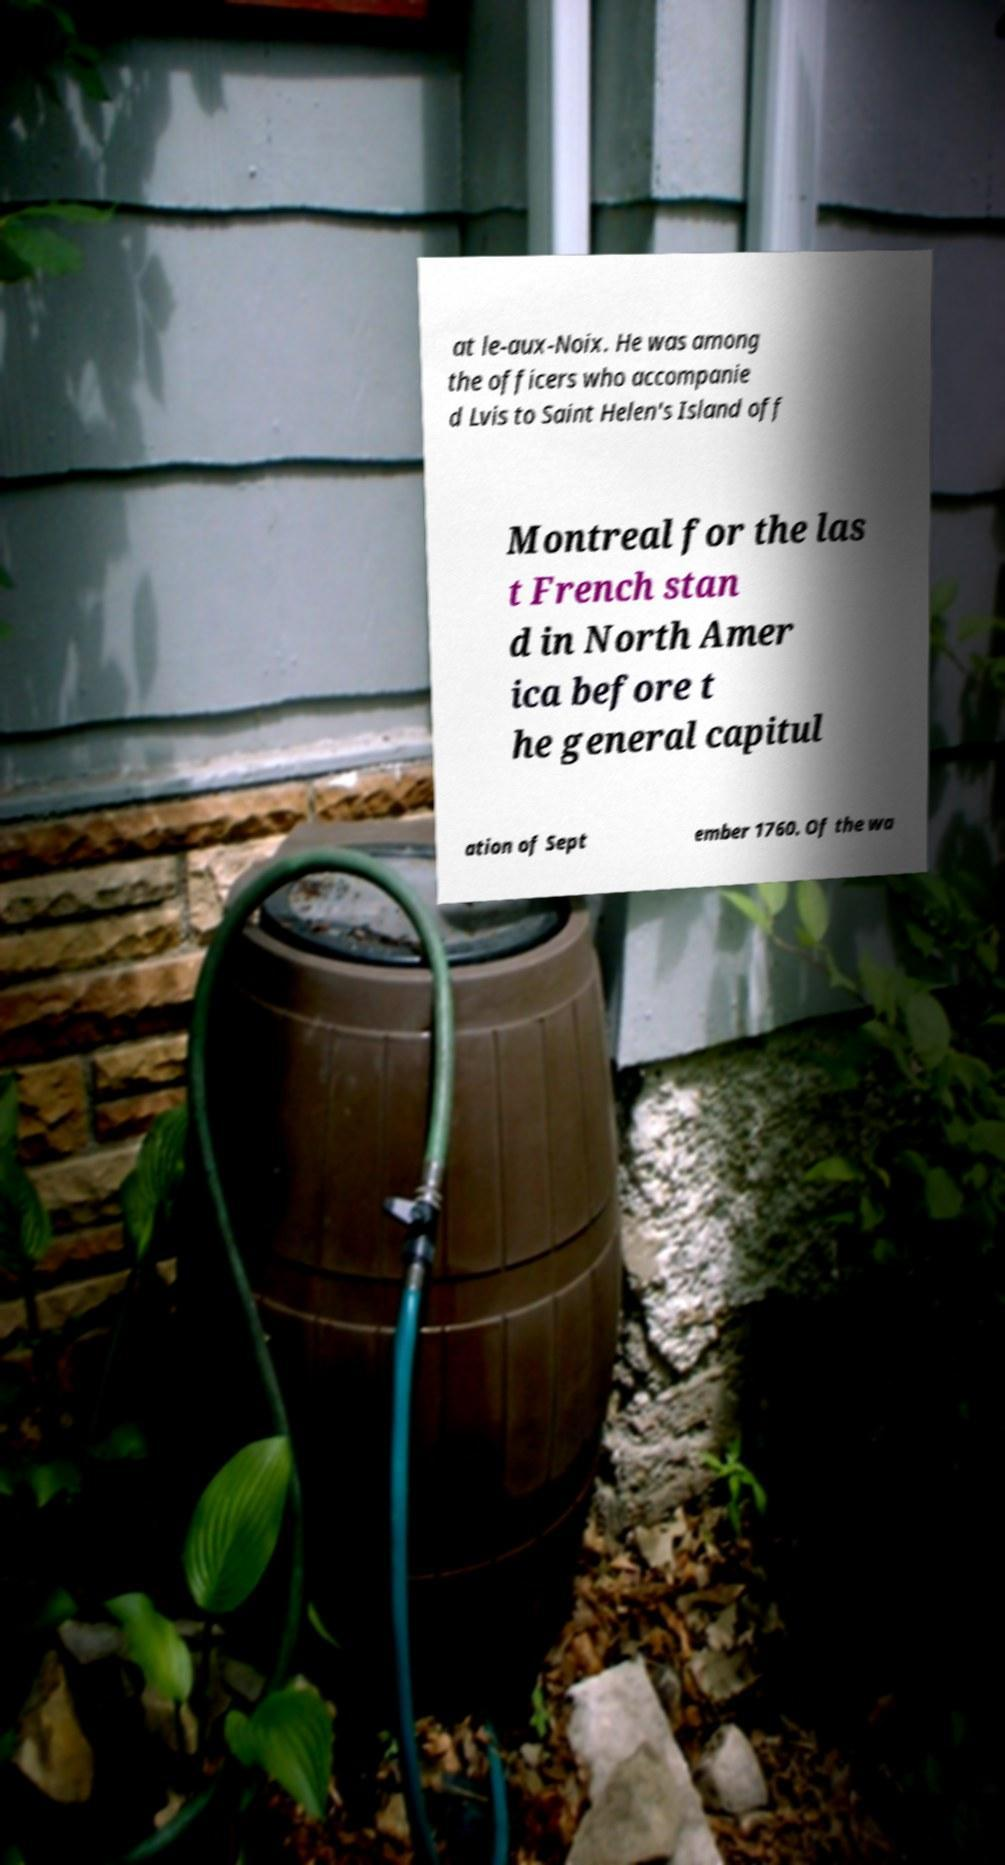Could you assist in decoding the text presented in this image and type it out clearly? at le-aux-Noix. He was among the officers who accompanie d Lvis to Saint Helen's Island off Montreal for the las t French stan d in North Amer ica before t he general capitul ation of Sept ember 1760. Of the wa 